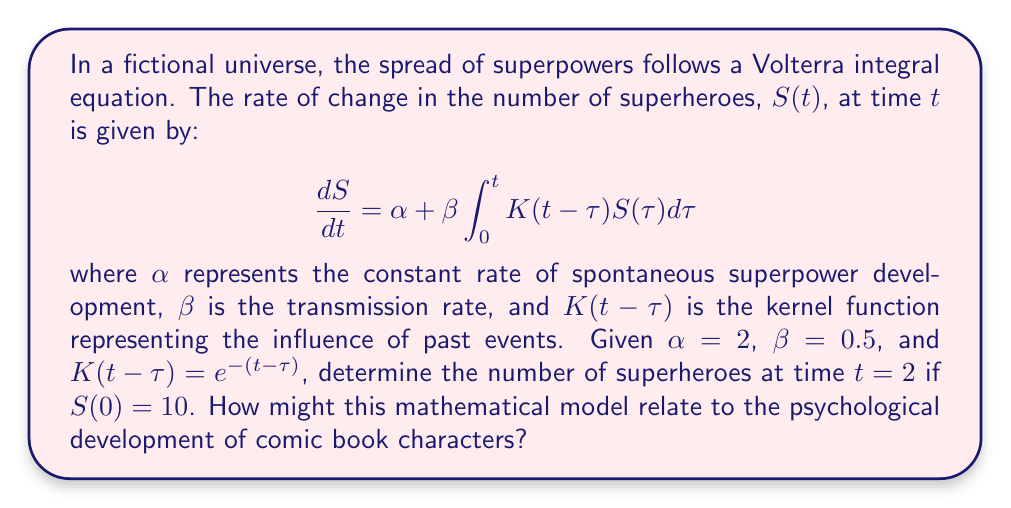Help me with this question. To solve this problem, we'll follow these steps:

1) First, we need to solve the Volterra integral equation. We can do this by converting it to a system of ordinary differential equations.

2) Let $I(t) = \int_0^t K(t-\tau)S(\tau)d\tau$. Then, $\frac{dI}{dt} = S(t) + \int_0^t \frac{\partial K(t-\tau)}{\partial t}S(\tau)d\tau$.

3) Given $K(t-\tau) = e^{-(t-\tau)}$, we have $\frac{\partial K(t-\tau)}{\partial t} = -e^{-(t-\tau)} = -K(t-\tau)$.

4) Substituting this back, we get:
   $$\frac{dI}{dt} = S(t) - I(t)$$

5) Now we have a system of ODEs:
   $$\frac{dS}{dt} = \alpha + \beta I(t)$$
   $$\frac{dI}{dt} = S(t) - I(t)$$

6) We can solve this system numerically using a method like Runge-Kutta. Using a numerical solver with the initial conditions $S(0) = 10$ and $I(0) = 0$, we find:
   $$S(2) \approx 18.76$$

7) Relating this to psychology: This model shows how superpowers (or traits) can spread through a population over time. In terms of character development, it could represent how certain character traits or abilities become more prevalent in comic book narratives over time, influenced by both spontaneous creation ($\alpha$) and the influence of existing characters ($\beta I(t)$).
Answer: $S(2) \approx 18.76$ superheroes 